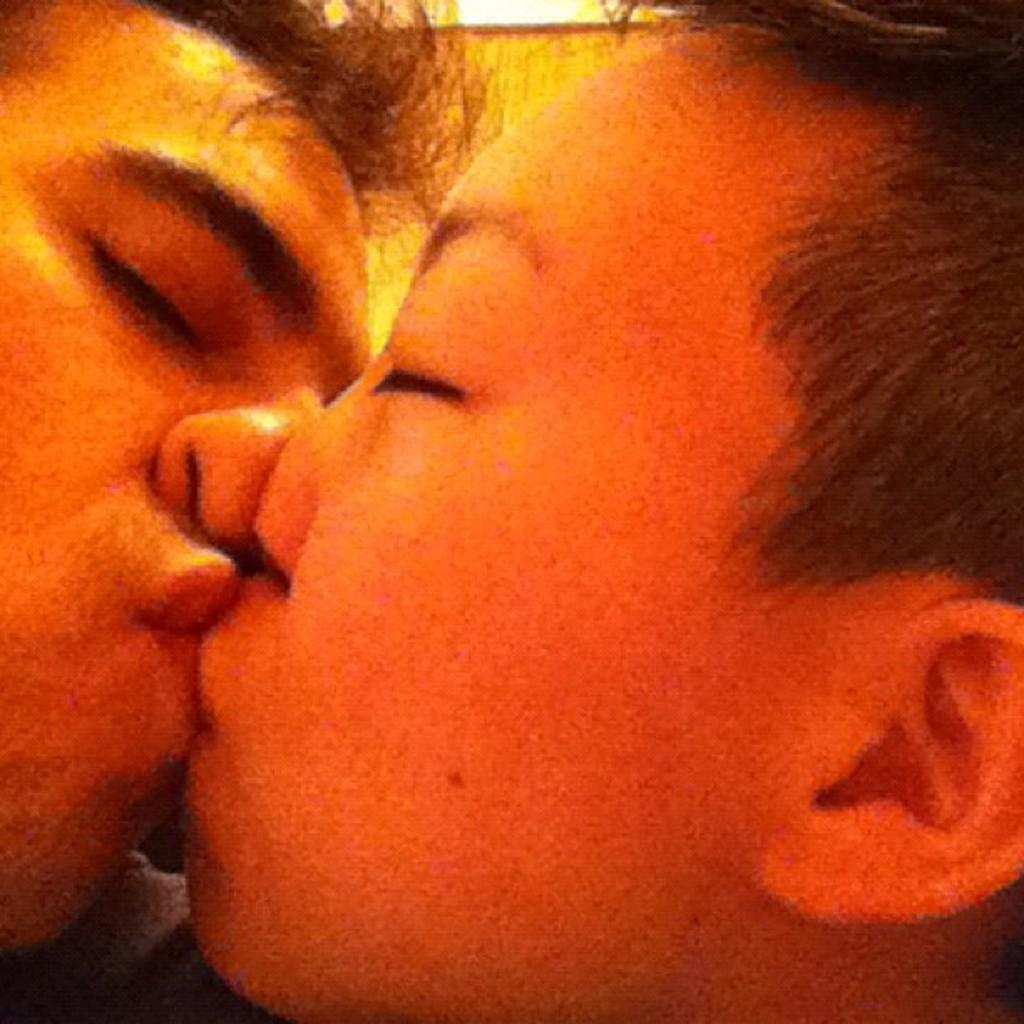How many people are in the image? There are two people in the image. What are the two people doing in the image? The two people are kissing each other. What type of zinc or marble material can be seen in the image? There is no zinc or marble material present in the image. Is there a horse visible in the image? No, there is no horse present in the image. 